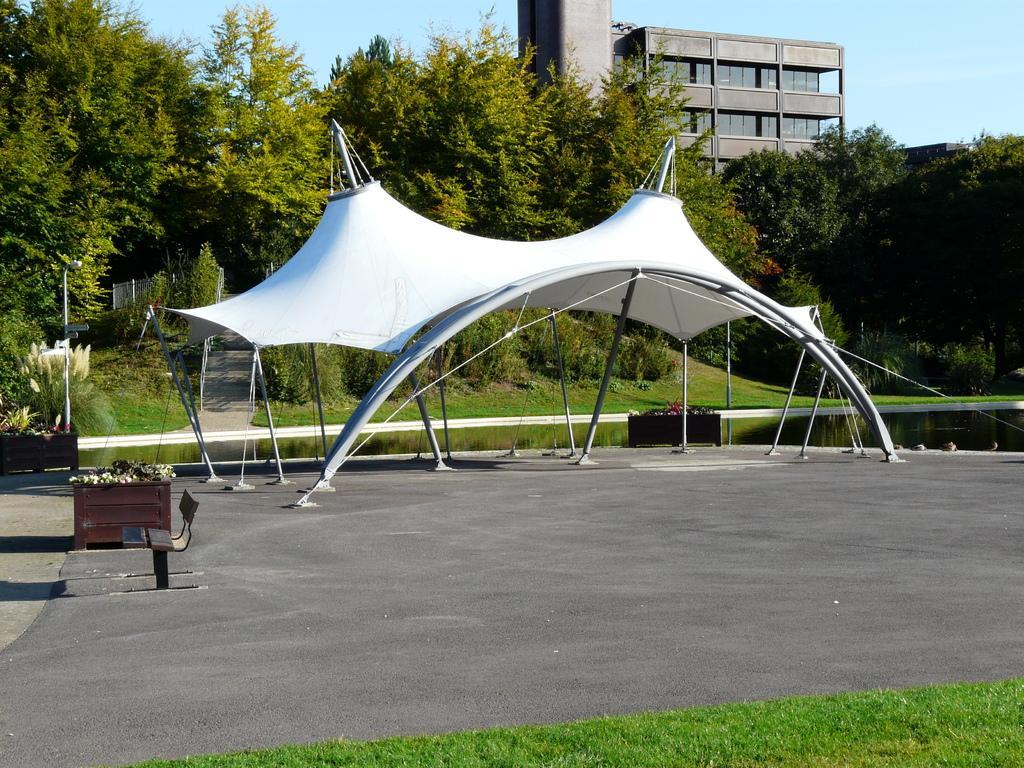Can you describe this image briefly? In this picture we can see some grass on the ground. There is a bench, street light and a tent on the path. We can see a few things in a wooden object. There are a few plants and trees visible in the background. 